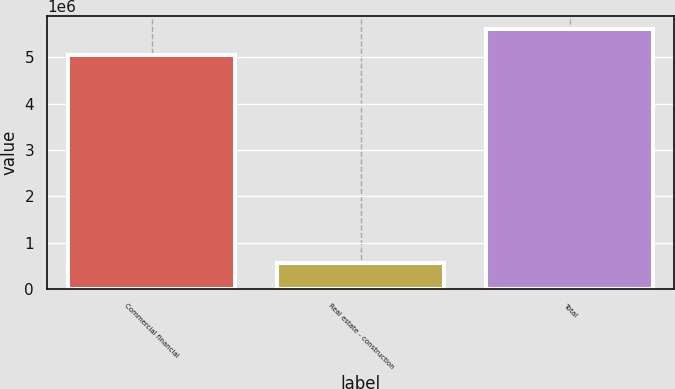<chart> <loc_0><loc_0><loc_500><loc_500><bar_chart><fcel>Commercial financial<fcel>Real estate - construction<fcel>Total<nl><fcel>5.0401e+06<fcel>565845<fcel>5.60594e+06<nl></chart> 